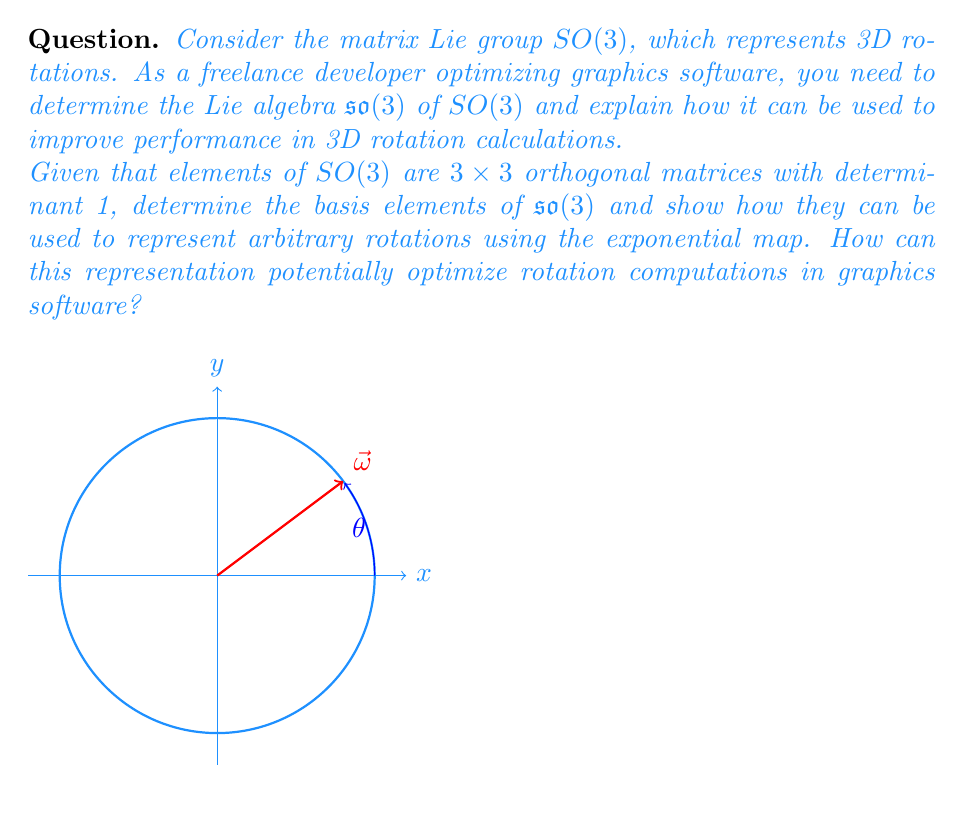Could you help me with this problem? To solve this problem, let's follow these steps:

1) First, we need to determine the Lie algebra $\mathfrak{so}(3)$ of $SO(3)$:
   - Elements of $SO(3)$ are $3 \times 3$ orthogonal matrices $R$ with $\det(R) = 1$.
   - The Lie algebra $\mathfrak{so}(3)$ consists of matrices $X$ such that $e^X \in SO(3)$.
   - This implies that $X$ must be skew-symmetric: $X^T = -X$.

2) The basis elements of $\mathfrak{so}(3)$ are:

   $$J_1 = \begin{pmatrix}
   0 & 0 & 0 \\
   0 & 0 & -1 \\
   0 & 1 & 0
   \end{pmatrix},
   J_2 = \begin{pmatrix}
   0 & 0 & 1 \\
   0 & 0 & 0 \\
   -1 & 0 & 0
   \end{pmatrix},
   J_3 = \begin{pmatrix}
   0 & -1 & 0 \\
   1 & 0 & 0 \\
   0 & 0 & 0
   \end{pmatrix}$$

3) Any element $X \in \mathfrak{so}(3)$ can be written as a linear combination:
   $$X = \omega_1 J_1 + \omega_2 J_2 + \omega_3 J_3$$
   where $\vec{\omega} = (\omega_1, \omega_2, \omega_3)$ represents the axis of rotation.

4) The exponential map $\exp: \mathfrak{so}(3) \to SO(3)$ gives us a way to convert elements of the Lie algebra to elements of the Lie group:
   $$R = e^X = I + \sin(\theta) \hat{\omega} + (1-\cos(\theta)) \hat{\omega}^2$$
   where $\theta = \|\vec{\omega}\|$ is the angle of rotation and $\hat{\omega}$ is the skew-symmetric matrix form of the normalized rotation axis.

5) This representation, known as the Rodrigues' rotation formula, can optimize rotation computations in graphics software:
   - Instead of storing and manipulating 9 elements of a rotation matrix, we only need to store 3 components of $\vec{\omega}$.
   - Composition of rotations can be approximated using the Baker-Campbell-Hausdorff formula in the Lie algebra, which is computationally cheaper than matrix multiplication.
   - Interpolation between rotations (e.g., for animation) becomes linear interpolation in the Lie algebra, which is more natural and avoids singularities.

6) Implementation in software:
   - Store rotations as 3D vectors $\vec{\omega}$ instead of matrices.
   - Use the exponential map only when needed to convert to matrix form.
   - Perform most operations (composition, interpolation) directly on these vectors.
   - This approach can lead to more compact storage, faster computations, and more stable numerical behavior in graphics applications.
Answer: $\mathfrak{so}(3)$ consists of $3 \times 3$ skew-symmetric matrices. Represent rotations as 3D vectors $\vec{\omega}$, use exponential map for conversion to matrices, and perform operations in the Lie algebra for optimized computations. 